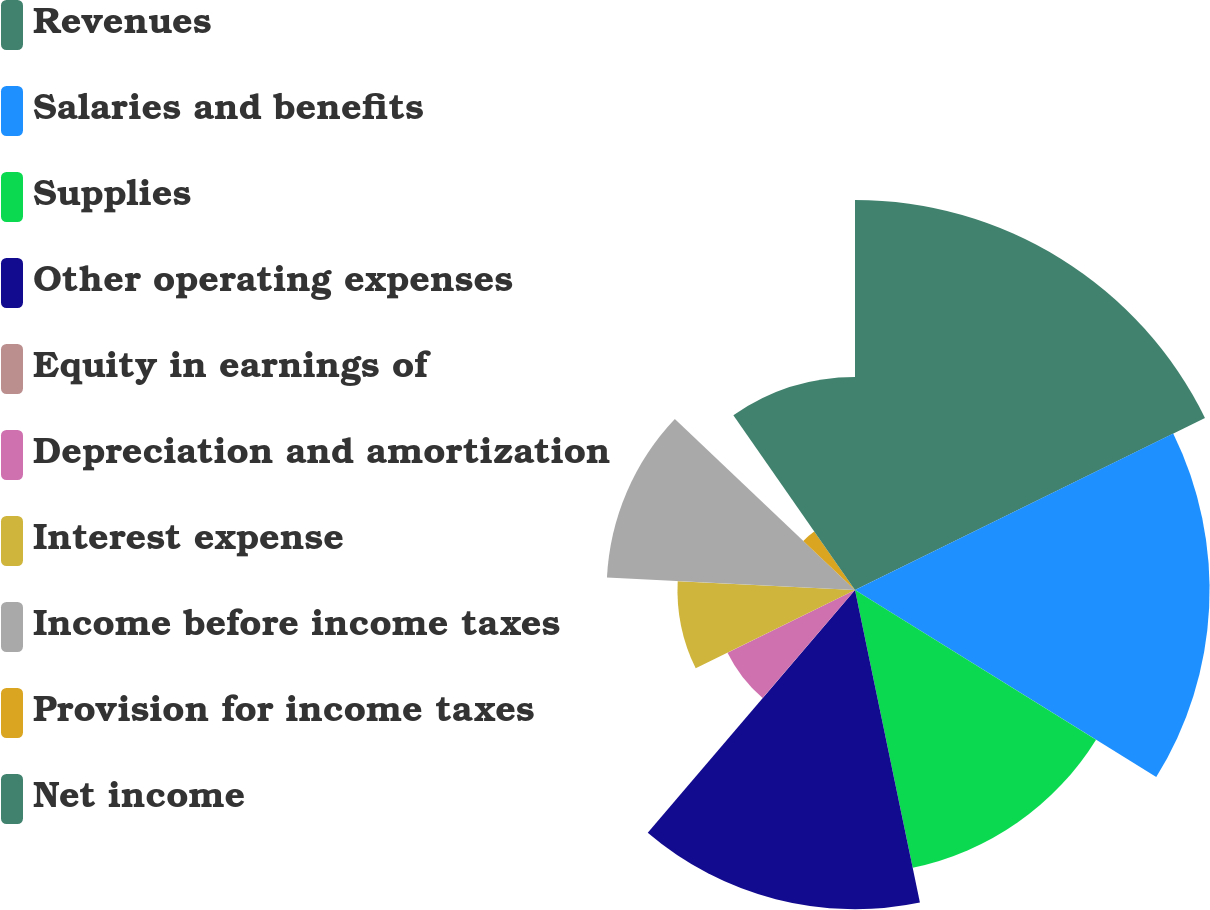Convert chart. <chart><loc_0><loc_0><loc_500><loc_500><pie_chart><fcel>Revenues<fcel>Salaries and benefits<fcel>Supplies<fcel>Other operating expenses<fcel>Equity in earnings of<fcel>Depreciation and amortization<fcel>Interest expense<fcel>Income before income taxes<fcel>Provision for income taxes<fcel>Net income<nl><fcel>17.73%<fcel>16.12%<fcel>12.9%<fcel>14.51%<fcel>0.02%<fcel>6.46%<fcel>8.07%<fcel>11.29%<fcel>3.24%<fcel>9.68%<nl></chart> 